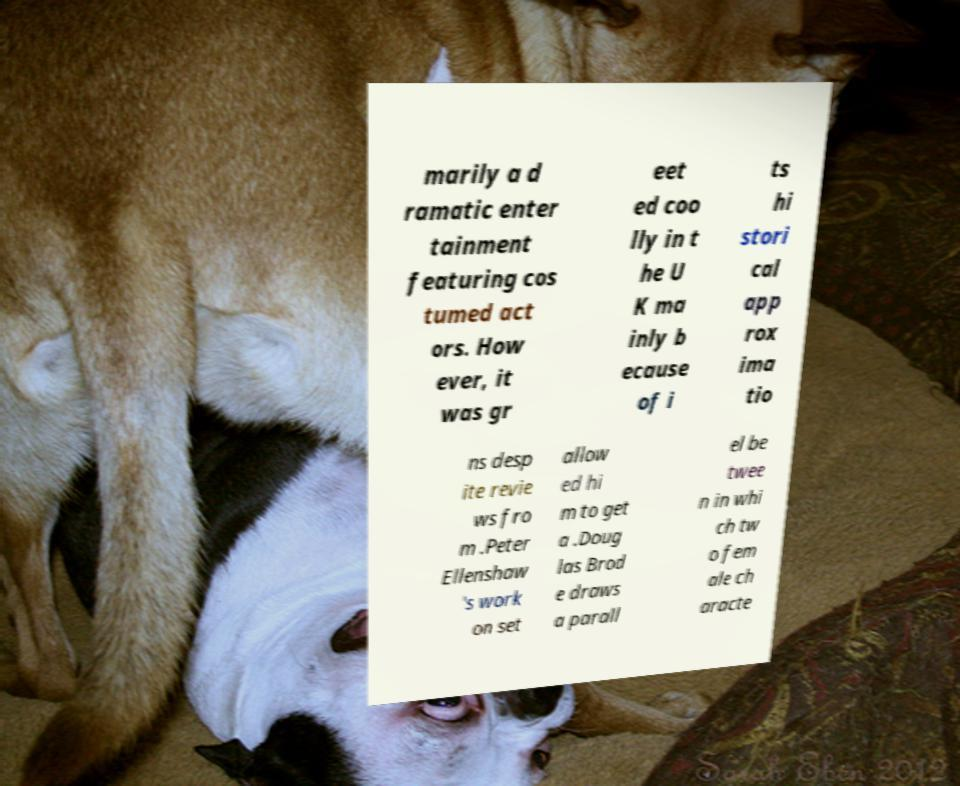Could you extract and type out the text from this image? marily a d ramatic enter tainment featuring cos tumed act ors. How ever, it was gr eet ed coo lly in t he U K ma inly b ecause of i ts hi stori cal app rox ima tio ns desp ite revie ws fro m .Peter Ellenshaw 's work on set allow ed hi m to get a .Doug las Brod e draws a parall el be twee n in whi ch tw o fem ale ch aracte 